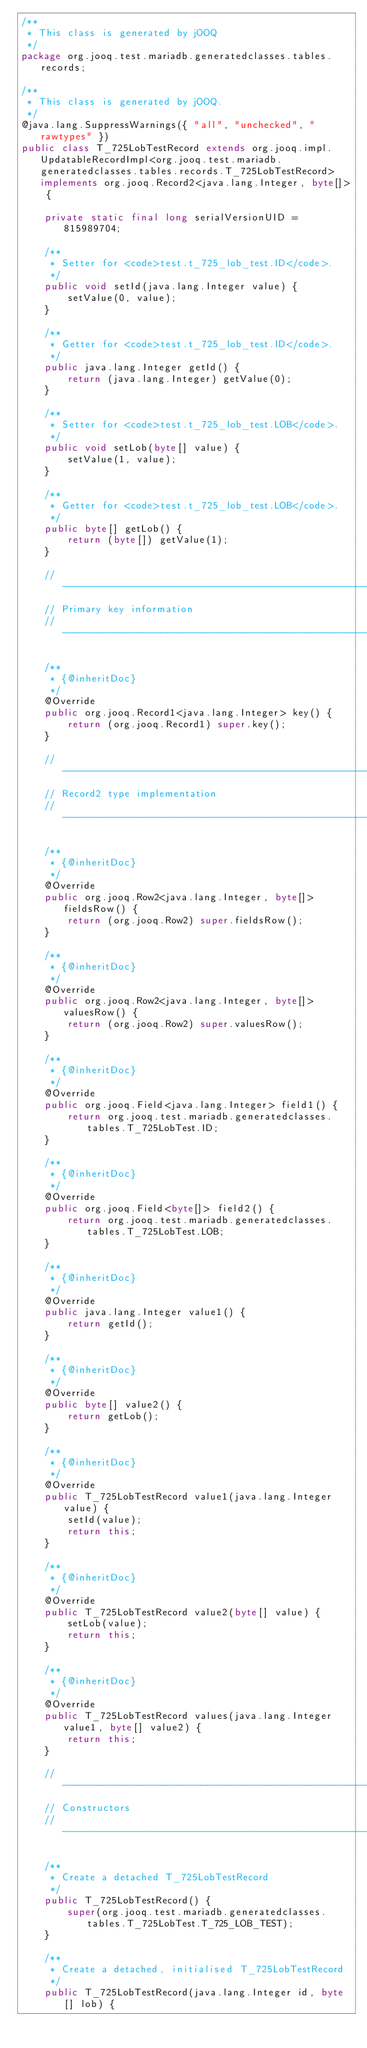<code> <loc_0><loc_0><loc_500><loc_500><_Java_>/**
 * This class is generated by jOOQ
 */
package org.jooq.test.mariadb.generatedclasses.tables.records;

/**
 * This class is generated by jOOQ.
 */
@java.lang.SuppressWarnings({ "all", "unchecked", "rawtypes" })
public class T_725LobTestRecord extends org.jooq.impl.UpdatableRecordImpl<org.jooq.test.mariadb.generatedclasses.tables.records.T_725LobTestRecord> implements org.jooq.Record2<java.lang.Integer, byte[]> {

	private static final long serialVersionUID = 815989704;

	/**
	 * Setter for <code>test.t_725_lob_test.ID</code>. 
	 */
	public void setId(java.lang.Integer value) {
		setValue(0, value);
	}

	/**
	 * Getter for <code>test.t_725_lob_test.ID</code>. 
	 */
	public java.lang.Integer getId() {
		return (java.lang.Integer) getValue(0);
	}

	/**
	 * Setter for <code>test.t_725_lob_test.LOB</code>. 
	 */
	public void setLob(byte[] value) {
		setValue(1, value);
	}

	/**
	 * Getter for <code>test.t_725_lob_test.LOB</code>. 
	 */
	public byte[] getLob() {
		return (byte[]) getValue(1);
	}

	// -------------------------------------------------------------------------
	// Primary key information
	// -------------------------------------------------------------------------

	/**
	 * {@inheritDoc}
	 */
	@Override
	public org.jooq.Record1<java.lang.Integer> key() {
		return (org.jooq.Record1) super.key();
	}

	// -------------------------------------------------------------------------
	// Record2 type implementation
	// -------------------------------------------------------------------------

	/**
	 * {@inheritDoc}
	 */
	@Override
	public org.jooq.Row2<java.lang.Integer, byte[]> fieldsRow() {
		return (org.jooq.Row2) super.fieldsRow();
	}

	/**
	 * {@inheritDoc}
	 */
	@Override
	public org.jooq.Row2<java.lang.Integer, byte[]> valuesRow() {
		return (org.jooq.Row2) super.valuesRow();
	}

	/**
	 * {@inheritDoc}
	 */
	@Override
	public org.jooq.Field<java.lang.Integer> field1() {
		return org.jooq.test.mariadb.generatedclasses.tables.T_725LobTest.ID;
	}

	/**
	 * {@inheritDoc}
	 */
	@Override
	public org.jooq.Field<byte[]> field2() {
		return org.jooq.test.mariadb.generatedclasses.tables.T_725LobTest.LOB;
	}

	/**
	 * {@inheritDoc}
	 */
	@Override
	public java.lang.Integer value1() {
		return getId();
	}

	/**
	 * {@inheritDoc}
	 */
	@Override
	public byte[] value2() {
		return getLob();
	}

	/**
	 * {@inheritDoc}
	 */
	@Override
	public T_725LobTestRecord value1(java.lang.Integer value) {
		setId(value);
		return this;
	}

	/**
	 * {@inheritDoc}
	 */
	@Override
	public T_725LobTestRecord value2(byte[] value) {
		setLob(value);
		return this;
	}

	/**
	 * {@inheritDoc}
	 */
	@Override
	public T_725LobTestRecord values(java.lang.Integer value1, byte[] value2) {
		return this;
	}

	// -------------------------------------------------------------------------
	// Constructors
	// -------------------------------------------------------------------------

	/**
	 * Create a detached T_725LobTestRecord
	 */
	public T_725LobTestRecord() {
		super(org.jooq.test.mariadb.generatedclasses.tables.T_725LobTest.T_725_LOB_TEST);
	}

	/**
	 * Create a detached, initialised T_725LobTestRecord
	 */
	public T_725LobTestRecord(java.lang.Integer id, byte[] lob) {</code> 